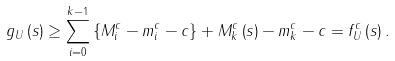<formula> <loc_0><loc_0><loc_500><loc_500>g _ { U } \left ( s \right ) \geq \sum _ { i = 0 } ^ { k - 1 } \left \{ M _ { i } ^ { c } - m _ { i } ^ { c } - c \right \} + M _ { k } ^ { c } \left ( s \right ) - m _ { k } ^ { c } - c = f _ { U } ^ { c } \left ( s \right ) .</formula> 